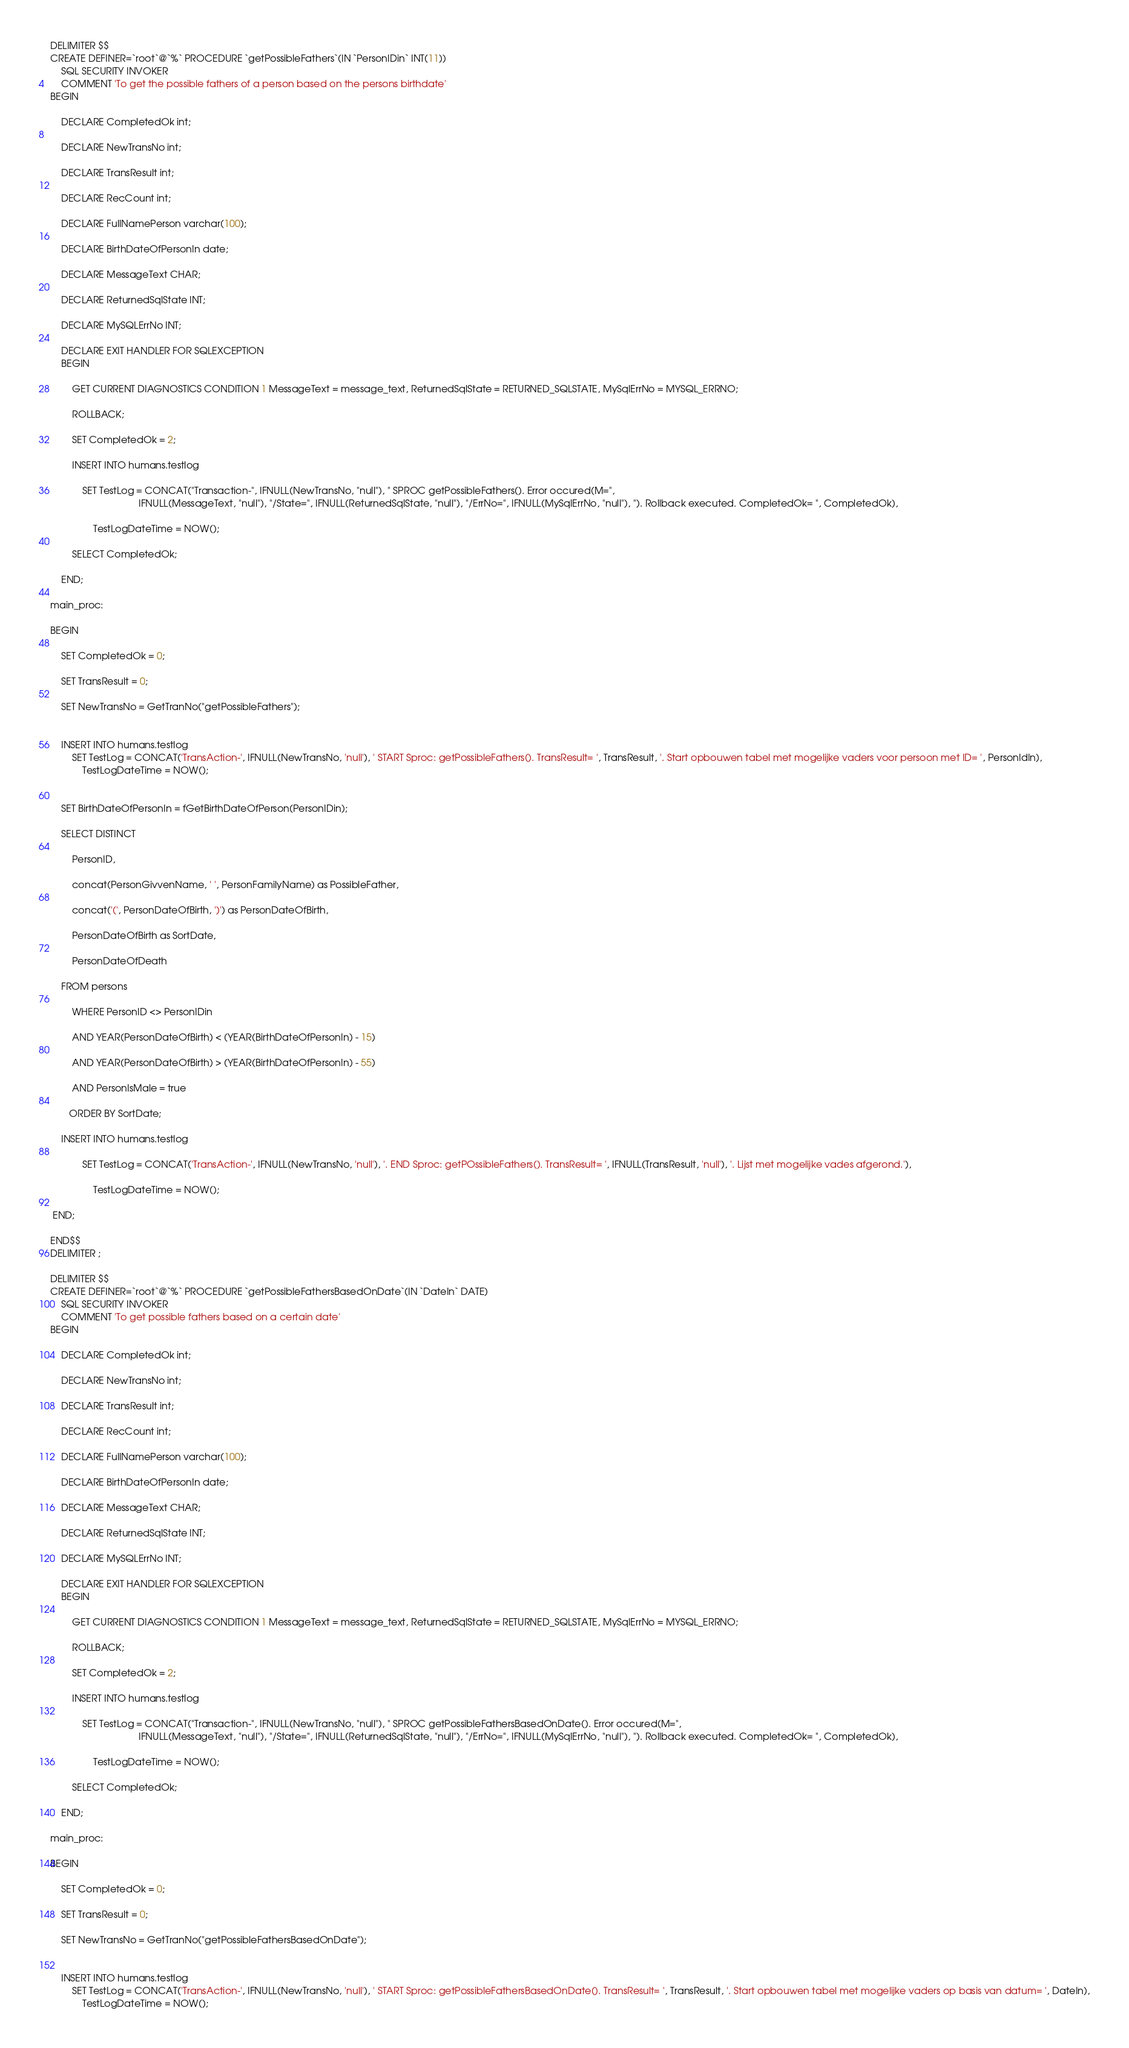<code> <loc_0><loc_0><loc_500><loc_500><_SQL_>DELIMITER $$
CREATE DEFINER=`root`@`%` PROCEDURE `getPossibleFathers`(IN `PersonIDin` INT(11))
    SQL SECURITY INVOKER
    COMMENT 'To get the possible fathers of a person based on the persons birthdate'
BEGIN

    DECLARE CompletedOk int;

	DECLARE NewTransNo int;

	DECLARE TransResult int;

	DECLARE RecCount int;

	DECLARE FullNamePerson varchar(100);

	DECLARE BirthDateOfPersonIn date;
    
	DECLARE MessageText CHAR;

	DECLARE ReturnedSqlState INT;

	DECLARE MySQLErrNo INT;
        
	DECLARE EXIT HANDLER FOR SQLEXCEPTION
 	BEGIN

		GET CURRENT DIAGNOSTICS CONDITION 1 MessageText = message_text, ReturnedSqlState = RETURNED_SQLSTATE, MySqlErrNo = MYSQL_ERRNO;
        
		ROLLBACK;

		SET CompletedOk = 2;

		INSERT INTO humans.testlog 

			SET TestLog = CONCAT("Transaction-", IFNULL(NewTransNo, "null"), " SPROC getPossibleFathers(). Error occured(M=", 
								 IFNULL(MessageText, "null"), "/State=", IFNULL(ReturnedSqlState, "null"), "/ErrNo=", IFNULL(MySqlErrNo, "null"), "). Rollback executed. CompletedOk= ", CompletedOk),

				TestLogDateTime = NOW();

		SELECT CompletedOk;

	END;

main_proc:

BEGIN

    SET CompletedOk = 0;

    SET TransResult = 0;

    SET NewTransNo = GetTranNo("getPossibleFathers");

    
    INSERT INTO humans.testlog 
		SET TestLog = CONCAT('TransAction-', IFNULL(NewTransNo, 'null'), ' START Sproc: getPossibleFathers(). TransResult= ', TransResult, '. Start opbouwen tabel met mogelijke vaders voor persoon met ID= ', PersonIdIn),
			TestLogDateTime = NOW();

    
    SET BirthDateOfPersonIn = fGetBirthDateOfPerson(PersonIDin);

	SELECT DISTINCT

		PersonID, 

		concat(PersonGivvenName, ' ', PersonFamilyName) as PossibleFather,
        
        concat('(', PersonDateOfBirth, ')') as PersonDateOfBirth,
        
        PersonDateOfBirth as SortDate,
        
        PersonDateOfDeath 
        
    FROM persons  

		WHERE PersonID <> PersonIDin

		AND YEAR(PersonDateOfBirth) < (YEAR(BirthDateOfPersonIn) - 15)

		AND YEAR(PersonDateOfBirth) > (YEAR(BirthDateOfPersonIn) - 55)
        
        AND PersonIsMale = true
        
       ORDER BY SortDate;

    INSERT INTO humans.testlog

			SET TestLog = CONCAT('TransAction-', IFNULL(NewTransNo, 'null'), '. END Sproc: getPOssibleFathers(). TransResult= ', IFNULL(TransResult, 'null'), '. Lijst met mogelijke vades afgerond.'),

				TestLogDateTime = NOW();

 END;

END$$
DELIMITER ;

DELIMITER $$
CREATE DEFINER=`root`@`%` PROCEDURE `getPossibleFathersBasedOnDate`(IN `DateIn` DATE)
    SQL SECURITY INVOKER
    COMMENT 'To get possible fathers based on a certain date'
BEGIN

    DECLARE CompletedOk int;

	DECLARE NewTransNo int;

	DECLARE TransResult int;

	DECLARE RecCount int;

	DECLARE FullNamePerson varchar(100);

	DECLARE BirthDateOfPersonIn date;
    
	DECLARE MessageText CHAR;

	DECLARE ReturnedSqlState INT;

	DECLARE MySQLErrNo INT;
        
	DECLARE EXIT HANDLER FOR SQLEXCEPTION
 	BEGIN

		GET CURRENT DIAGNOSTICS CONDITION 1 MessageText = message_text, ReturnedSqlState = RETURNED_SQLSTATE, MySqlErrNo = MYSQL_ERRNO;
        
		ROLLBACK;

		SET CompletedOk = 2;

		INSERT INTO humans.testlog 

			SET TestLog = CONCAT("Transaction-", IFNULL(NewTransNo, "null"), " SPROC getPossibleFathersBasedOnDate(). Error occured(M=", 
								 IFNULL(MessageText, "null"), "/State=", IFNULL(ReturnedSqlState, "null"), "/ErrNo=", IFNULL(MySqlErrNo, "null"), "). Rollback executed. CompletedOk= ", CompletedOk),

				TestLogDateTime = NOW();

		SELECT CompletedOk;

	END;

main_proc:

BEGIN

    SET CompletedOk = 0;

    SET TransResult = 0;

    SET NewTransNo = GetTranNo("getPossibleFathersBasedOnDate");

    
    INSERT INTO humans.testlog 
		SET TestLog = CONCAT('TransAction-', IFNULL(NewTransNo, 'null'), ' START Sproc: getPossibleFathersBasedOnDate(). TransResult= ', TransResult, '. Start opbouwen tabel met mogelijke vaders op basis van datum= ', DateIn),
			TestLogDateTime = NOW();</code> 